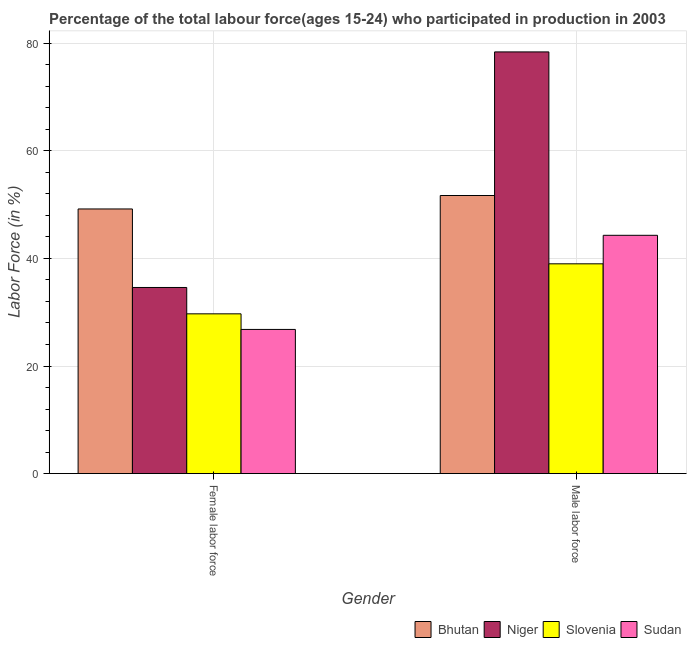How many different coloured bars are there?
Make the answer very short. 4. How many bars are there on the 2nd tick from the left?
Ensure brevity in your answer.  4. What is the label of the 2nd group of bars from the left?
Ensure brevity in your answer.  Male labor force. What is the percentage of female labor force in Bhutan?
Provide a short and direct response. 49.2. Across all countries, what is the maximum percentage of female labor force?
Make the answer very short. 49.2. In which country was the percentage of female labor force maximum?
Provide a succinct answer. Bhutan. In which country was the percentage of male labour force minimum?
Provide a short and direct response. Slovenia. What is the total percentage of female labor force in the graph?
Ensure brevity in your answer.  140.3. What is the difference between the percentage of female labor force in Bhutan and that in Slovenia?
Provide a succinct answer. 19.5. What is the difference between the percentage of female labor force in Sudan and the percentage of male labour force in Bhutan?
Keep it short and to the point. -24.9. What is the average percentage of male labour force per country?
Provide a short and direct response. 53.35. What is the difference between the percentage of male labour force and percentage of female labor force in Niger?
Your answer should be compact. 43.8. In how many countries, is the percentage of male labour force greater than 12 %?
Provide a succinct answer. 4. What is the ratio of the percentage of female labor force in Niger to that in Sudan?
Keep it short and to the point. 1.29. Is the percentage of female labor force in Sudan less than that in Bhutan?
Your answer should be compact. Yes. In how many countries, is the percentage of female labor force greater than the average percentage of female labor force taken over all countries?
Keep it short and to the point. 1. What does the 2nd bar from the left in Female labor force represents?
Provide a succinct answer. Niger. What does the 1st bar from the right in Male labor force represents?
Offer a very short reply. Sudan. How many countries are there in the graph?
Make the answer very short. 4. Does the graph contain any zero values?
Make the answer very short. No. Does the graph contain grids?
Keep it short and to the point. Yes. Where does the legend appear in the graph?
Make the answer very short. Bottom right. How many legend labels are there?
Give a very brief answer. 4. What is the title of the graph?
Your answer should be compact. Percentage of the total labour force(ages 15-24) who participated in production in 2003. Does "Jordan" appear as one of the legend labels in the graph?
Offer a very short reply. No. What is the label or title of the Y-axis?
Your answer should be very brief. Labor Force (in %). What is the Labor Force (in %) in Bhutan in Female labor force?
Offer a terse response. 49.2. What is the Labor Force (in %) in Niger in Female labor force?
Ensure brevity in your answer.  34.6. What is the Labor Force (in %) in Slovenia in Female labor force?
Offer a very short reply. 29.7. What is the Labor Force (in %) of Sudan in Female labor force?
Your response must be concise. 26.8. What is the Labor Force (in %) in Bhutan in Male labor force?
Your answer should be compact. 51.7. What is the Labor Force (in %) of Niger in Male labor force?
Offer a very short reply. 78.4. What is the Labor Force (in %) in Slovenia in Male labor force?
Ensure brevity in your answer.  39. What is the Labor Force (in %) of Sudan in Male labor force?
Offer a terse response. 44.3. Across all Gender, what is the maximum Labor Force (in %) of Bhutan?
Make the answer very short. 51.7. Across all Gender, what is the maximum Labor Force (in %) in Niger?
Offer a very short reply. 78.4. Across all Gender, what is the maximum Labor Force (in %) of Sudan?
Provide a succinct answer. 44.3. Across all Gender, what is the minimum Labor Force (in %) in Bhutan?
Your response must be concise. 49.2. Across all Gender, what is the minimum Labor Force (in %) of Niger?
Ensure brevity in your answer.  34.6. Across all Gender, what is the minimum Labor Force (in %) of Slovenia?
Provide a succinct answer. 29.7. Across all Gender, what is the minimum Labor Force (in %) in Sudan?
Give a very brief answer. 26.8. What is the total Labor Force (in %) in Bhutan in the graph?
Your response must be concise. 100.9. What is the total Labor Force (in %) of Niger in the graph?
Make the answer very short. 113. What is the total Labor Force (in %) of Slovenia in the graph?
Make the answer very short. 68.7. What is the total Labor Force (in %) in Sudan in the graph?
Your answer should be very brief. 71.1. What is the difference between the Labor Force (in %) in Niger in Female labor force and that in Male labor force?
Make the answer very short. -43.8. What is the difference between the Labor Force (in %) in Slovenia in Female labor force and that in Male labor force?
Ensure brevity in your answer.  -9.3. What is the difference between the Labor Force (in %) in Sudan in Female labor force and that in Male labor force?
Your response must be concise. -17.5. What is the difference between the Labor Force (in %) of Bhutan in Female labor force and the Labor Force (in %) of Niger in Male labor force?
Offer a terse response. -29.2. What is the difference between the Labor Force (in %) in Bhutan in Female labor force and the Labor Force (in %) in Sudan in Male labor force?
Your answer should be very brief. 4.9. What is the difference between the Labor Force (in %) in Niger in Female labor force and the Labor Force (in %) in Sudan in Male labor force?
Ensure brevity in your answer.  -9.7. What is the difference between the Labor Force (in %) of Slovenia in Female labor force and the Labor Force (in %) of Sudan in Male labor force?
Give a very brief answer. -14.6. What is the average Labor Force (in %) of Bhutan per Gender?
Your answer should be compact. 50.45. What is the average Labor Force (in %) of Niger per Gender?
Your answer should be compact. 56.5. What is the average Labor Force (in %) in Slovenia per Gender?
Your response must be concise. 34.35. What is the average Labor Force (in %) in Sudan per Gender?
Provide a short and direct response. 35.55. What is the difference between the Labor Force (in %) in Bhutan and Labor Force (in %) in Slovenia in Female labor force?
Keep it short and to the point. 19.5. What is the difference between the Labor Force (in %) of Bhutan and Labor Force (in %) of Sudan in Female labor force?
Your answer should be very brief. 22.4. What is the difference between the Labor Force (in %) of Niger and Labor Force (in %) of Slovenia in Female labor force?
Offer a very short reply. 4.9. What is the difference between the Labor Force (in %) of Niger and Labor Force (in %) of Sudan in Female labor force?
Your answer should be compact. 7.8. What is the difference between the Labor Force (in %) in Bhutan and Labor Force (in %) in Niger in Male labor force?
Offer a terse response. -26.7. What is the difference between the Labor Force (in %) in Bhutan and Labor Force (in %) in Slovenia in Male labor force?
Your response must be concise. 12.7. What is the difference between the Labor Force (in %) in Niger and Labor Force (in %) in Slovenia in Male labor force?
Keep it short and to the point. 39.4. What is the difference between the Labor Force (in %) in Niger and Labor Force (in %) in Sudan in Male labor force?
Your answer should be compact. 34.1. What is the ratio of the Labor Force (in %) in Bhutan in Female labor force to that in Male labor force?
Provide a short and direct response. 0.95. What is the ratio of the Labor Force (in %) in Niger in Female labor force to that in Male labor force?
Offer a very short reply. 0.44. What is the ratio of the Labor Force (in %) in Slovenia in Female labor force to that in Male labor force?
Offer a terse response. 0.76. What is the ratio of the Labor Force (in %) in Sudan in Female labor force to that in Male labor force?
Your answer should be compact. 0.6. What is the difference between the highest and the second highest Labor Force (in %) in Niger?
Your answer should be compact. 43.8. What is the difference between the highest and the second highest Labor Force (in %) in Sudan?
Your answer should be compact. 17.5. What is the difference between the highest and the lowest Labor Force (in %) in Niger?
Your response must be concise. 43.8. What is the difference between the highest and the lowest Labor Force (in %) of Sudan?
Your answer should be compact. 17.5. 